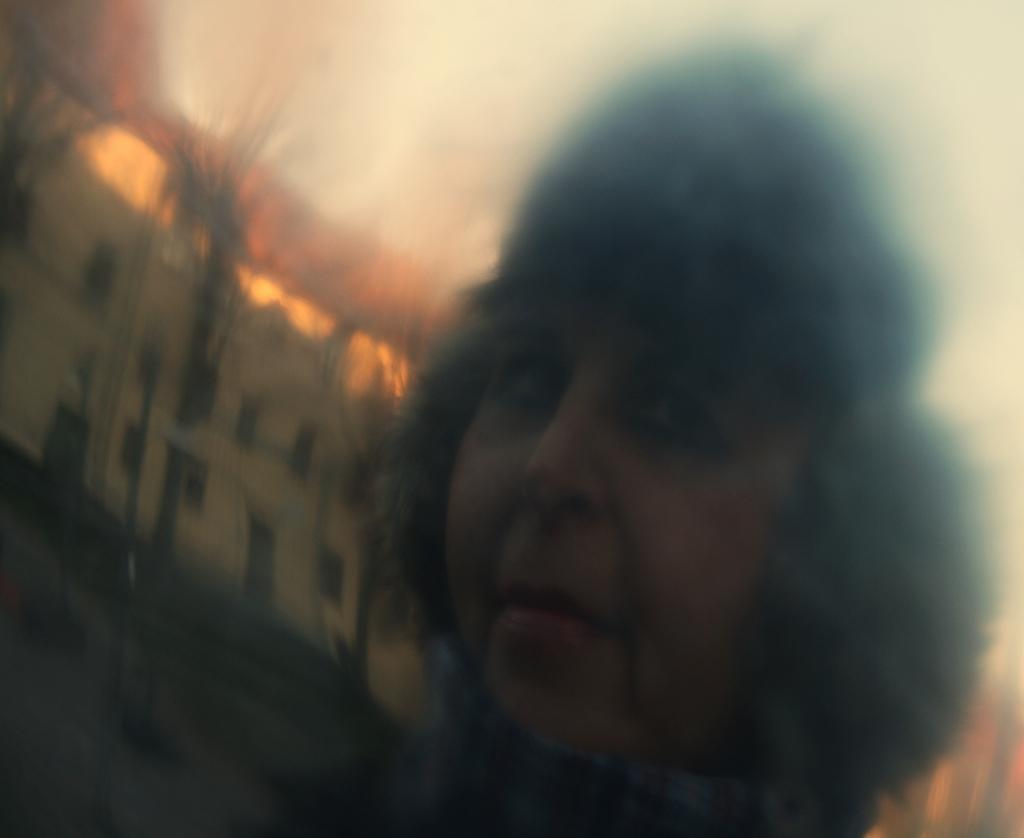Describe this image in one or two sentences. This is a blur image. In this image we can see a person. In the back there is a building. 